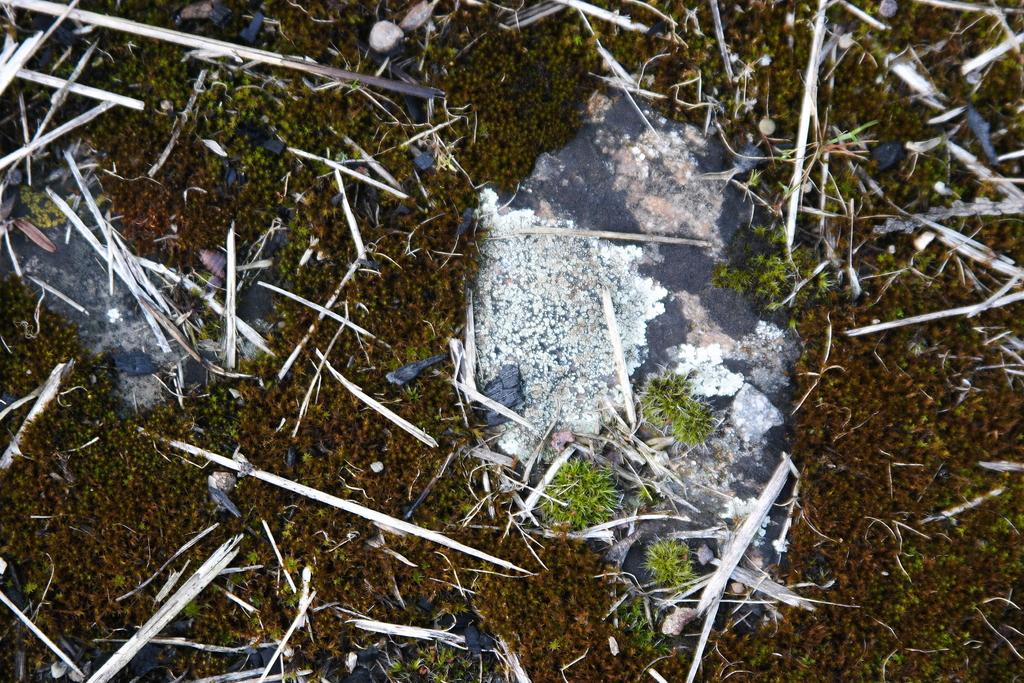What objects are present in the image? There are tooth pricks and dry straws in the image. Where are these objects located? Both objects are on the land. What type of yarn is the scarecrow holding in the image? There is no scarecrow present in the image, and therefore no such activity can be observed. What type of thread is visible connecting the tooth pricks and dry straws? There is no thread connecting the tooth pricks and dry straws in the image. 